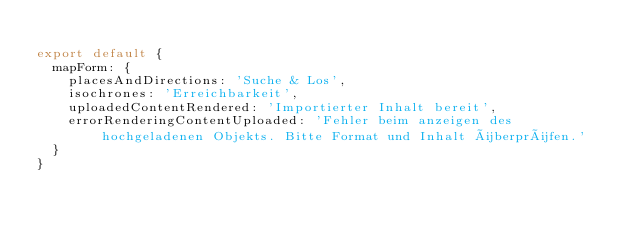<code> <loc_0><loc_0><loc_500><loc_500><_JavaScript_>
export default {
  mapForm: {
    placesAndDirections: 'Suche & Los',
    isochrones: 'Erreichbarkeit',
    uploadedContentRendered: 'Importierter Inhalt bereit',
    errorRenderingContentUploaded: 'Fehler beim anzeigen des hochgeladenen Objekts. Bitte Format und Inhalt überprüfen.'
  }
}
</code> 